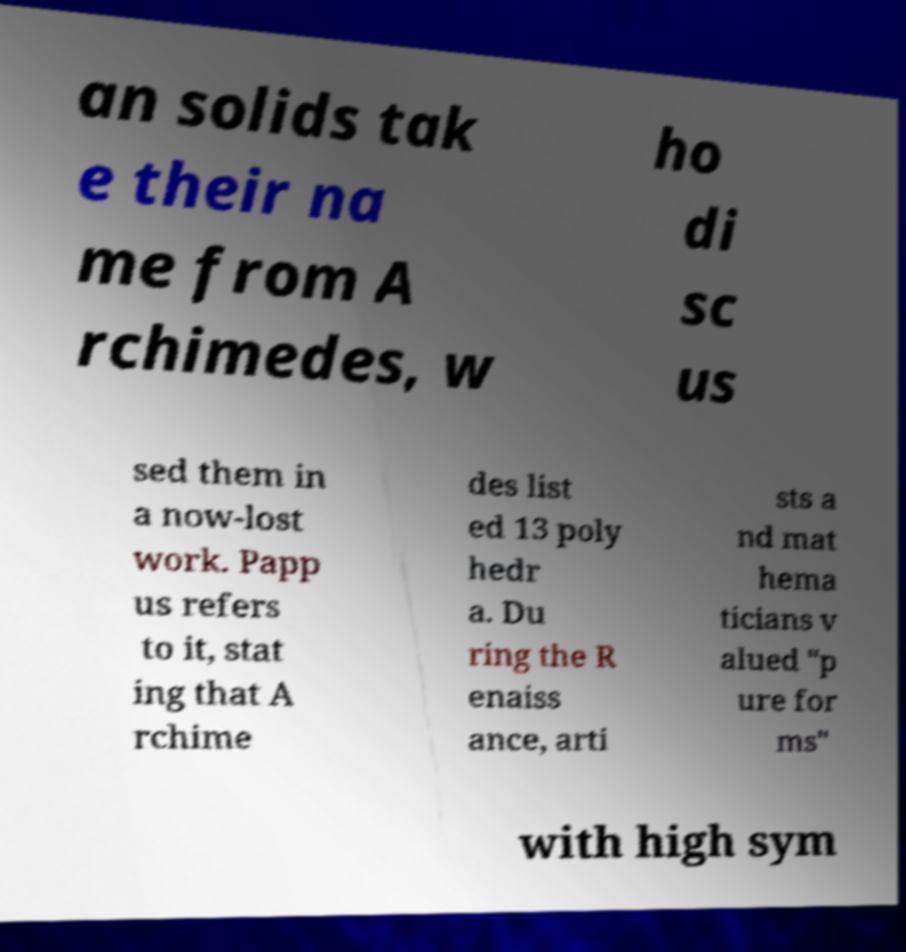I need the written content from this picture converted into text. Can you do that? an solids tak e their na me from A rchimedes, w ho di sc us sed them in a now-lost work. Papp us refers to it, stat ing that A rchime des list ed 13 poly hedr a. Du ring the R enaiss ance, arti sts a nd mat hema ticians v alued "p ure for ms" with high sym 